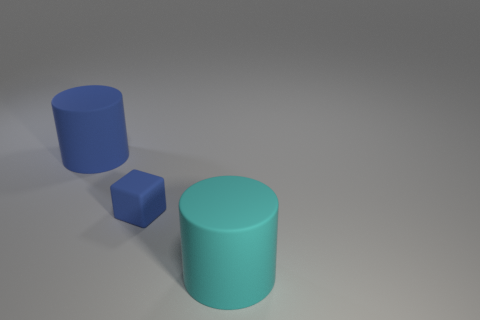There is a big matte cylinder behind the tiny blue matte thing; is its color the same as the small object?
Your answer should be very brief. Yes. Is there anything else that is the same color as the small rubber thing?
Provide a short and direct response. Yes. Does the cylinder to the left of the small blue object have the same color as the tiny matte cube that is to the right of the big blue cylinder?
Offer a terse response. Yes. What number of rubber cylinders have the same color as the tiny cube?
Give a very brief answer. 1. There is a large object on the right side of the rubber cylinder that is behind the tiny rubber thing; how many blue cubes are left of it?
Provide a short and direct response. 1. Is the number of tiny blue things in front of the big cyan cylinder the same as the number of blue rubber cylinders?
Provide a short and direct response. No. How many cylinders are either rubber objects or big cyan things?
Make the answer very short. 2. Is the number of tiny blue matte cubes that are behind the blue matte cylinder the same as the number of big blue things that are to the right of the small blue matte cube?
Give a very brief answer. Yes. What is the color of the small rubber cube?
Offer a terse response. Blue. How many things are either blue matte objects that are on the left side of the blue cube or blue cubes?
Offer a terse response. 2. 